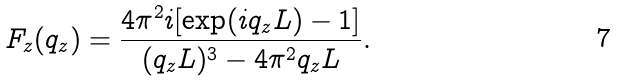Convert formula to latex. <formula><loc_0><loc_0><loc_500><loc_500>F _ { z } ( q _ { z } ) = \frac { 4 \pi ^ { 2 } i [ \exp ( i q _ { z } L ) - 1 ] } { ( q _ { z } L ) ^ { 3 } - 4 \pi ^ { 2 } q _ { z } L } .</formula> 